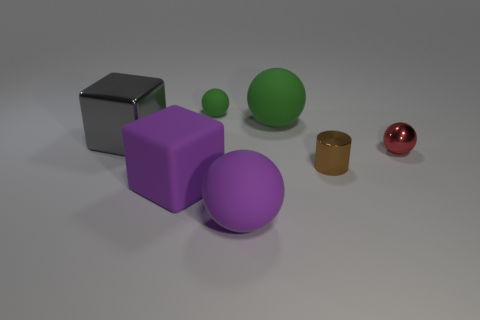There is a big purple matte sphere; what number of big purple matte balls are to the left of it?
Provide a short and direct response. 0. What number of things are either big rubber spheres or big gray shiny objects?
Your answer should be compact. 3. There is a object that is both in front of the tiny red sphere and behind the purple block; what is its shape?
Your answer should be compact. Cylinder. How many large balls are there?
Offer a very short reply. 2. The big object that is made of the same material as the small cylinder is what color?
Ensure brevity in your answer.  Gray. Are there more large gray metallic things than red blocks?
Provide a succinct answer. Yes. What is the size of the ball that is behind the big matte cube and in front of the big metal thing?
Make the answer very short. Small. There is a sphere that is the same color as the big matte cube; what is it made of?
Ensure brevity in your answer.  Rubber. Are there an equal number of big green rubber things to the left of the big purple cube and small matte objects?
Provide a succinct answer. No. Does the gray metal thing have the same size as the shiny ball?
Give a very brief answer. No. 